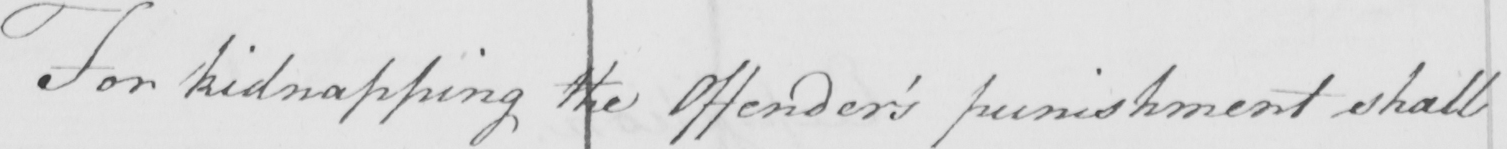Transcribe the text shown in this historical manuscript line. For kidnapping the Offender ' s punishment shall 